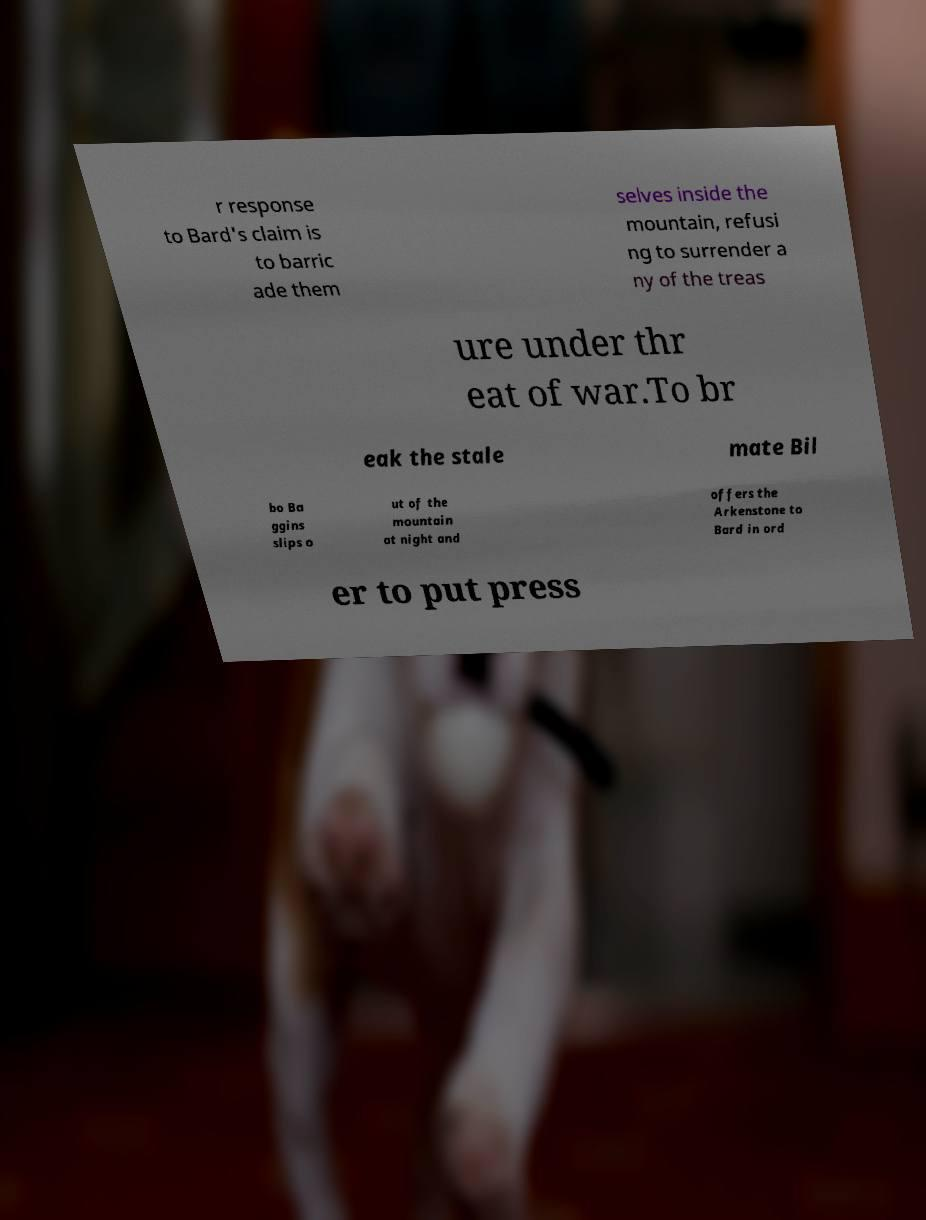There's text embedded in this image that I need extracted. Can you transcribe it verbatim? r response to Bard's claim is to barric ade them selves inside the mountain, refusi ng to surrender a ny of the treas ure under thr eat of war.To br eak the stale mate Bil bo Ba ggins slips o ut of the mountain at night and offers the Arkenstone to Bard in ord er to put press 